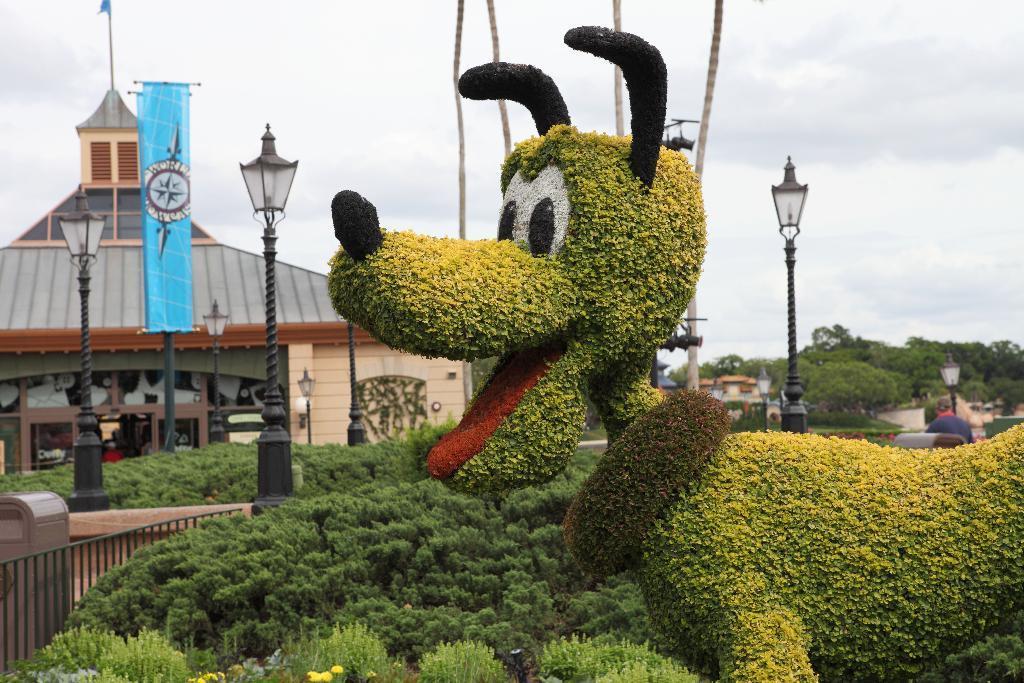Please provide a concise description of this image. On the right side of the image we can see a grass statue. At the bottom there are bushes. In the background there are poles, building, ropes and sky and we can see trees. 